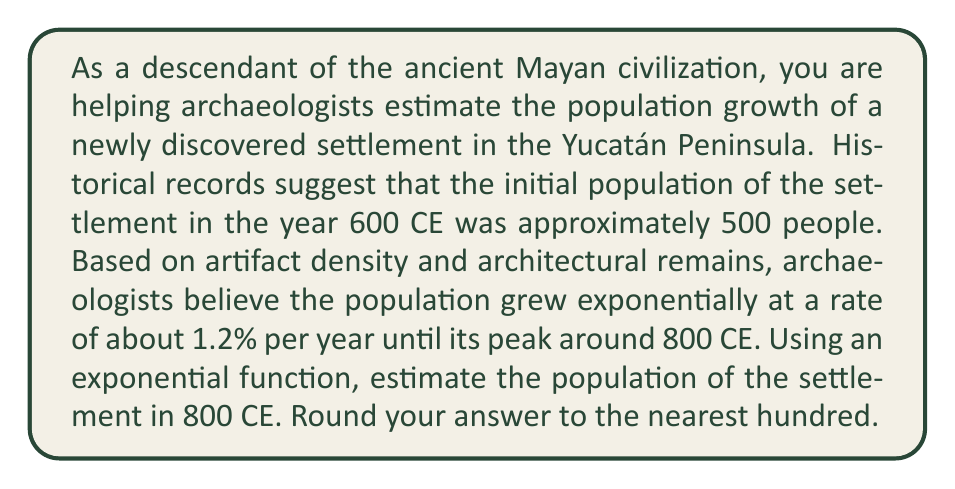Teach me how to tackle this problem. To solve this problem, we'll use the exponential growth function:

$$P(t) = P_0 \cdot e^{rt}$$

Where:
$P(t)$ is the population at time $t$
$P_0$ is the initial population
$e$ is Euler's number (approximately 2.71828)
$r$ is the growth rate (as a decimal)
$t$ is the time elapsed

Given:
$P_0 = 500$ (initial population in 600 CE)
$r = 0.012$ (1.2% annual growth rate)
$t = 200$ years (from 600 CE to 800 CE)

Let's substitute these values into the equation:

$$P(200) = 500 \cdot e^{0.012 \cdot 200}$$

Now, let's solve this step-by-step:

1) First, calculate the exponent:
   $0.012 \cdot 200 = 2.4$

2) Our equation now looks like this:
   $$P(200) = 500 \cdot e^{2.4}$$

3) Calculate $e^{2.4}$:
   $e^{2.4} \approx 11.0232$

4) Multiply by the initial population:
   $500 \cdot 11.0232 = 5,511.6$

5) Round to the nearest hundred:
   $5,511.6 \approx 5,500$

Therefore, the estimated population of the settlement in 800 CE was approximately 5,500 people.
Answer: 5,500 people 